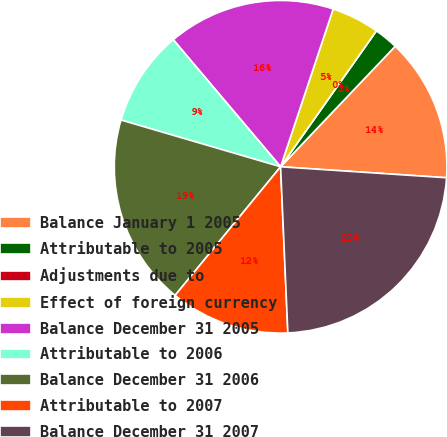Convert chart. <chart><loc_0><loc_0><loc_500><loc_500><pie_chart><fcel>Balance January 1 2005<fcel>Attributable to 2005<fcel>Adjustments due to<fcel>Effect of foreign currency<fcel>Balance December 31 2005<fcel>Attributable to 2006<fcel>Balance December 31 2006<fcel>Attributable to 2007<fcel>Balance December 31 2007<nl><fcel>13.95%<fcel>2.33%<fcel>0.0%<fcel>4.65%<fcel>16.28%<fcel>9.3%<fcel>18.6%<fcel>11.63%<fcel>23.25%<nl></chart> 